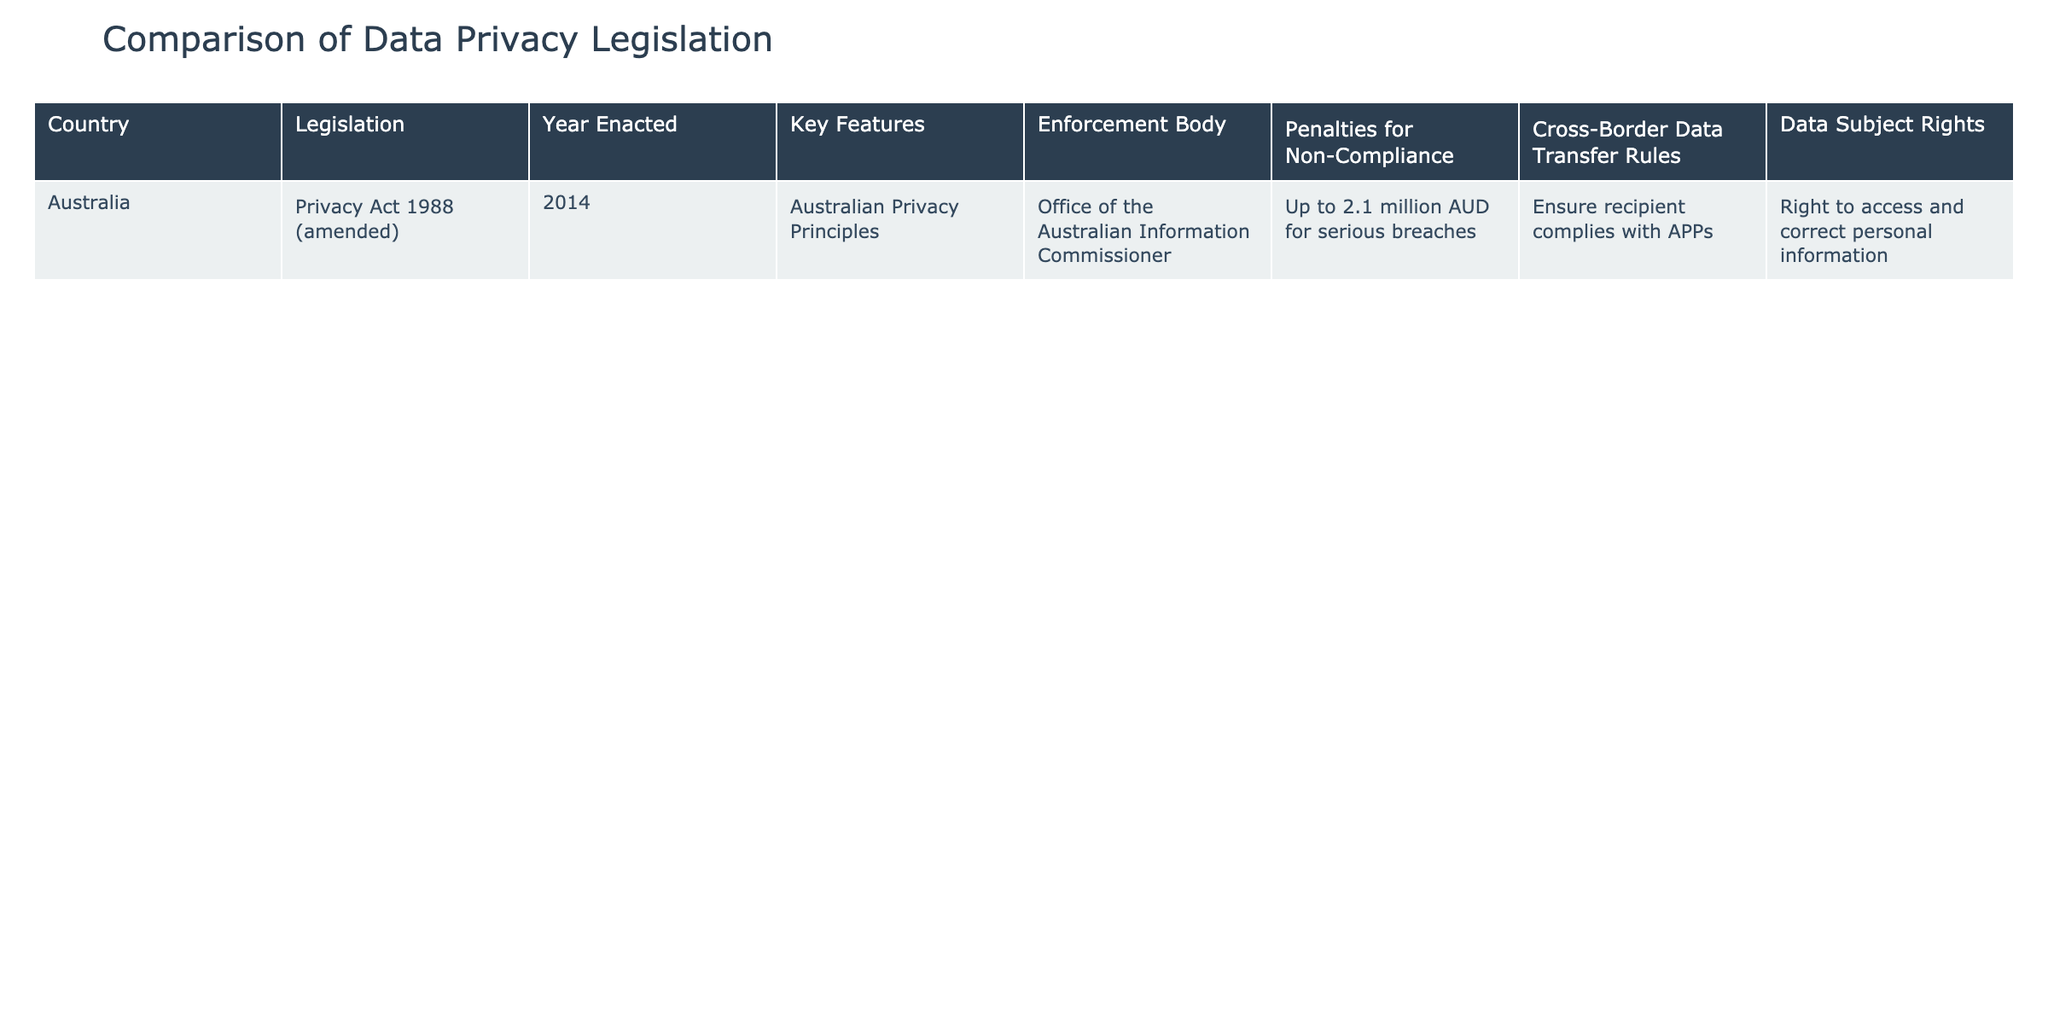What is the year in which the Privacy Act was enacted in Australia? The table specifies that the "Year Enacted" for the Privacy Act in Australia is listed as 2014.
Answer: 2014 What are the key features of Australia’s data privacy legislation? The "Key Features" column for Australia lists "Australian Privacy Principles" as the key feature of the Privacy Act.
Answer: Australian Privacy Principles What is the penalty for serious breaches of data privacy in Australia? According to the table, the penalty for serious breaches in Australia is "Up to 2.1 million AUD for serious breaches."
Answer: Up to 2.1 million AUD Does Australia allow for cross-border data transfer? The table shows that Australia requires the recipient to ensure compliance with Australian Privacy Principles (APPs) for cross-border data transfers, implying that it does allow such transfers under certain conditions.
Answer: Yes How do the penalties for non-compliance compare with the year the legislation was enacted? The table lists the penalty as "Up to 2.1 million AUD for serious breaches" while the legislation was enacted in 2014 (not numerical values to average or compare). Since there's only one data point, there’s no complex calculation outside of stating the penalty along with the year.
Answer: The penalty is 2.1 million AUD in 2014 